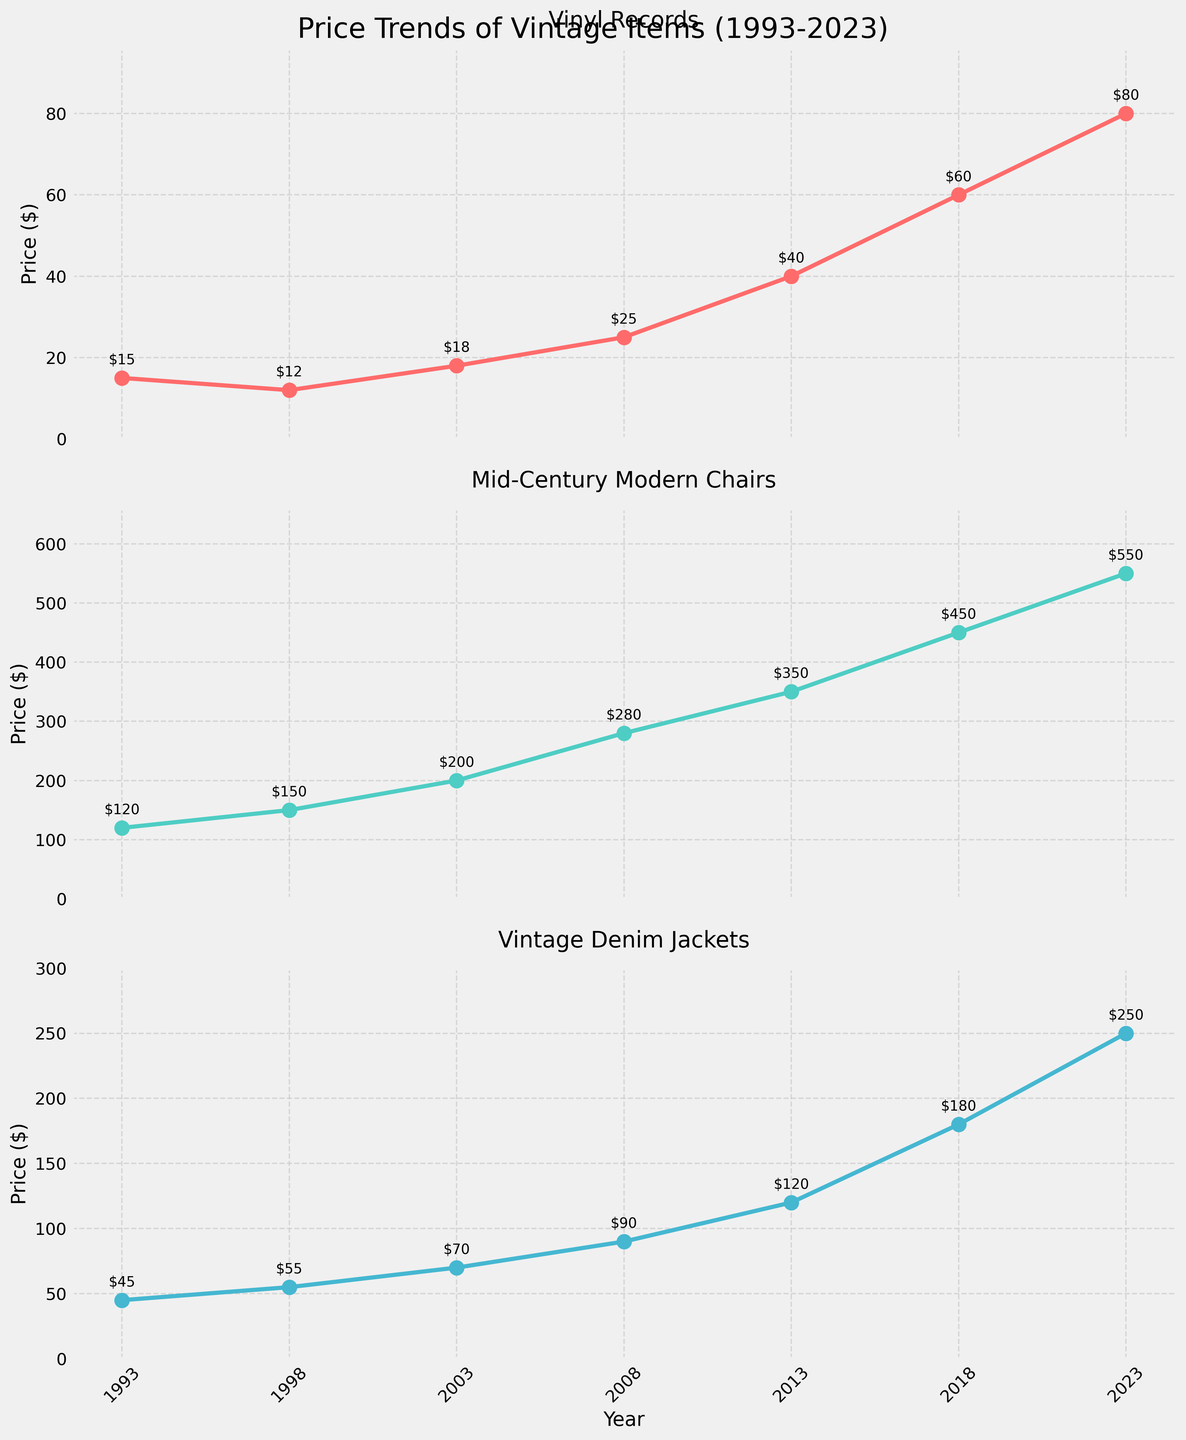What's the title of the figure? The title is located at the top center of the figure in a large font size. It is meant to summarize the main subject of the figure.
Answer: Price Trends of Vintage Items (1993-2023) What is the price of Vintage Denim Jackets in 2008? Locate the line corresponding to "Vintage Denim Jackets," then find the data point for the year 2008 on that line. Follow the point horizontally to the y-axis to determine the price.
Answer: $90 Which vintage item had the highest price in 2023? Look at the endpoint of each line on the right side (2023). Identify which of the three lines is the highest. The Mid-Century Modern Chairs line peaks the highest.
Answer: Mid-Century Modern Chairs By how much did the price of Vinyl Records increase from 2013 to 2023? Locate the price of Vinyl Records in 2013 and 2023 on its respective line. Subtract the 2013 value ($40) from the 2023 value ($80) to find the increase.
Answer: $40 What is the average price of Vinyl Records over the 30 years? Add up all the prices of Vinyl Records from each year and divide by the number of data points. ($15 + $12 + $18 + $25 + $40 + $60 + $80) / 7
Answer: $35.71 Between Mid-Century Modern Chairs and Vintage Denim Jackets, which had a steeper price increase between 2008 and 2018? Compare the increase for Mid-Century Modern Chairs from 280 to 450, and for Vintage Denim Jackets from 90 to 180. For Mid-Century Modern Chairs, the increase is 450 - 280 = 170. For Vintage Denim Jackets, the increase is 180 - 90 = 90. Since 170 is greater than 90, Mid-Century Modern Chairs had a steeper increase.
Answer: Mid-Century Modern Chairs What year did Vinyl Records start surpassing $20 in price? Refer to the plot line for Vinyl Records and find the first year where the price is above $20 by checking the y-axis labels corresponding to the points on the line.
Answer: 2008 Compare the overall price trend for the three items. Which line shows the most significant growth over the 30 years? Analyze the slope of each line from start to finish. Mid-Century Modern Chairs go from 120 to 550, Vintage Denim Jackets from 45 to 250, and Vinyl Records from 15 to 80. The steepest change in price indicates the most significant growth. The slope for Mid-Century Modern Chairs appears the largest.
Answer: Mid-Century Modern Chairs What is the color used for the line representing Vintage Denim Jackets? Identify the line for Vintage Denim Jackets and look at its color. The item corresponding to this line is colored light blue.
Answer: Light blue 